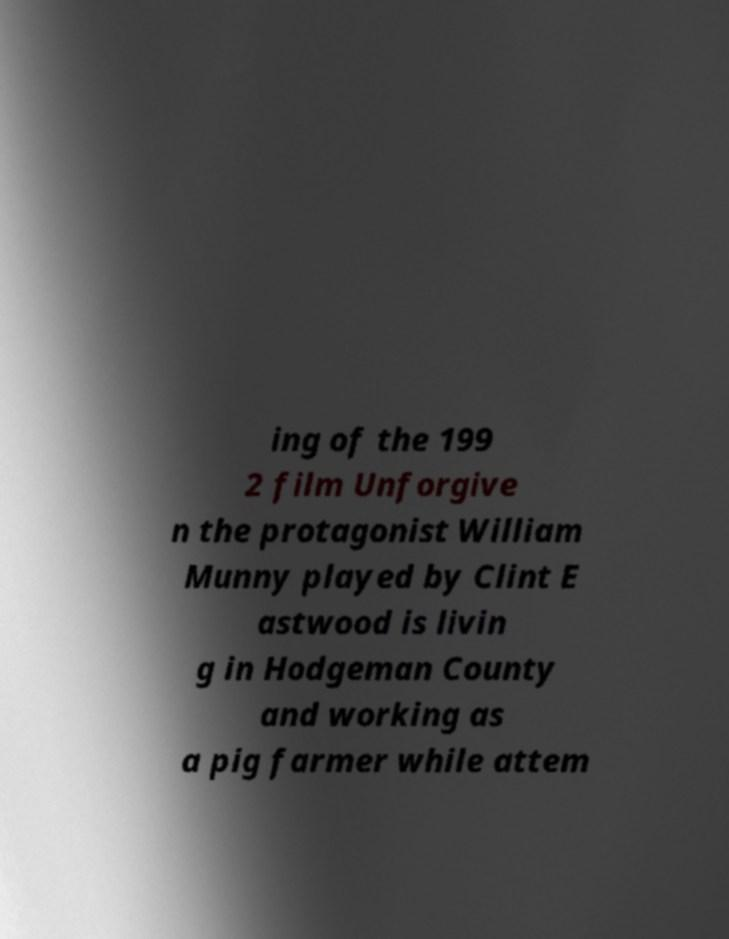I need the written content from this picture converted into text. Can you do that? ing of the 199 2 film Unforgive n the protagonist William Munny played by Clint E astwood is livin g in Hodgeman County and working as a pig farmer while attem 